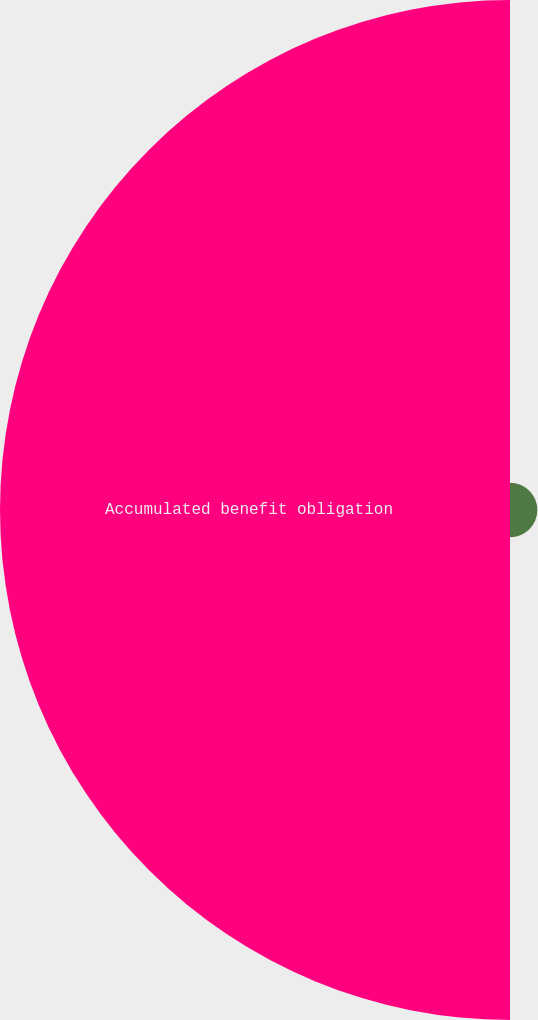Convert chart. <chart><loc_0><loc_0><loc_500><loc_500><pie_chart><fcel>Total of service and interest<fcel>Accumulated benefit obligation<nl><fcel>5.09%<fcel>94.91%<nl></chart> 